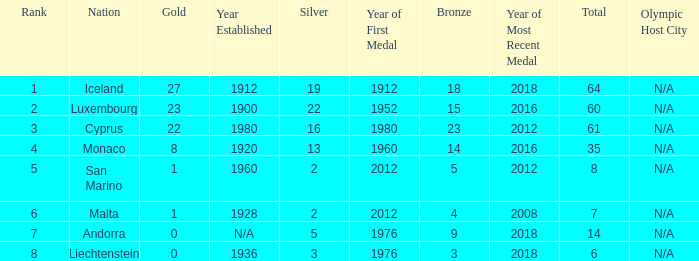How many bronzes for Iceland with over 2 silvers? 18.0. 